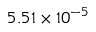Convert formula to latex. <formula><loc_0><loc_0><loc_500><loc_500>5 . 5 1 \times 1 0 ^ { - 5 }</formula> 